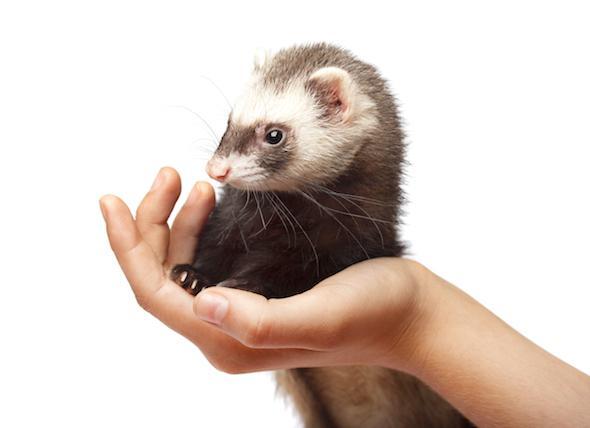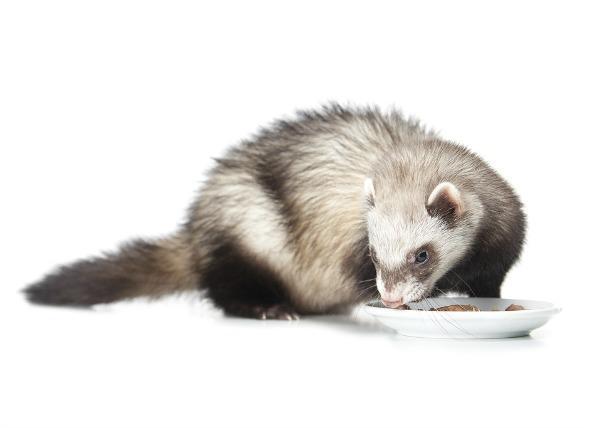The first image is the image on the left, the second image is the image on the right. Considering the images on both sides, is "One image shows a ferret standing behind a bowl of food, with its tail extending to the left and its head turned leftward." valid? Answer yes or no. Yes. The first image is the image on the left, the second image is the image on the right. Examine the images to the left and right. Is the description "A ferret is eating out of a dish." accurate? Answer yes or no. Yes. 